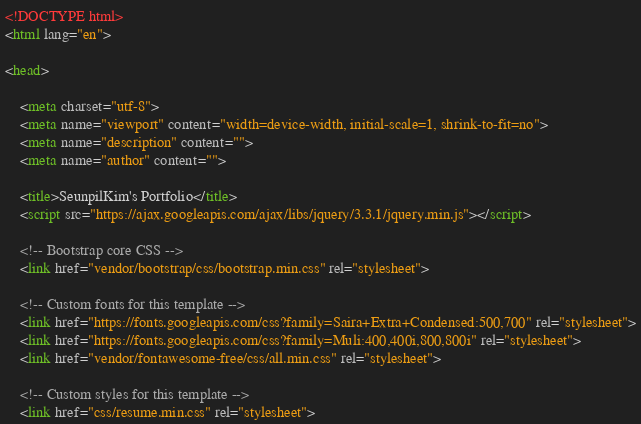<code> <loc_0><loc_0><loc_500><loc_500><_HTML_><!DOCTYPE html>
<html lang="en">

<head>

    <meta charset="utf-8">
    <meta name="viewport" content="width=device-width, initial-scale=1, shrink-to-fit=no">
    <meta name="description" content="">
    <meta name="author" content="">

    <title>SeunpilKim's Portfolio</title>
    <script src="https://ajax.googleapis.com/ajax/libs/jquery/3.3.1/jquery.min.js"></script>

    <!-- Bootstrap core CSS -->
    <link href="vendor/bootstrap/css/bootstrap.min.css" rel="stylesheet">

    <!-- Custom fonts for this template -->
    <link href="https://fonts.googleapis.com/css?family=Saira+Extra+Condensed:500,700" rel="stylesheet">
    <link href="https://fonts.googleapis.com/css?family=Muli:400,400i,800,800i" rel="stylesheet">
    <link href="vendor/fontawesome-free/css/all.min.css" rel="stylesheet">

    <!-- Custom styles for this template -->
    <link href="css/resume.min.css" rel="stylesheet"></code> 